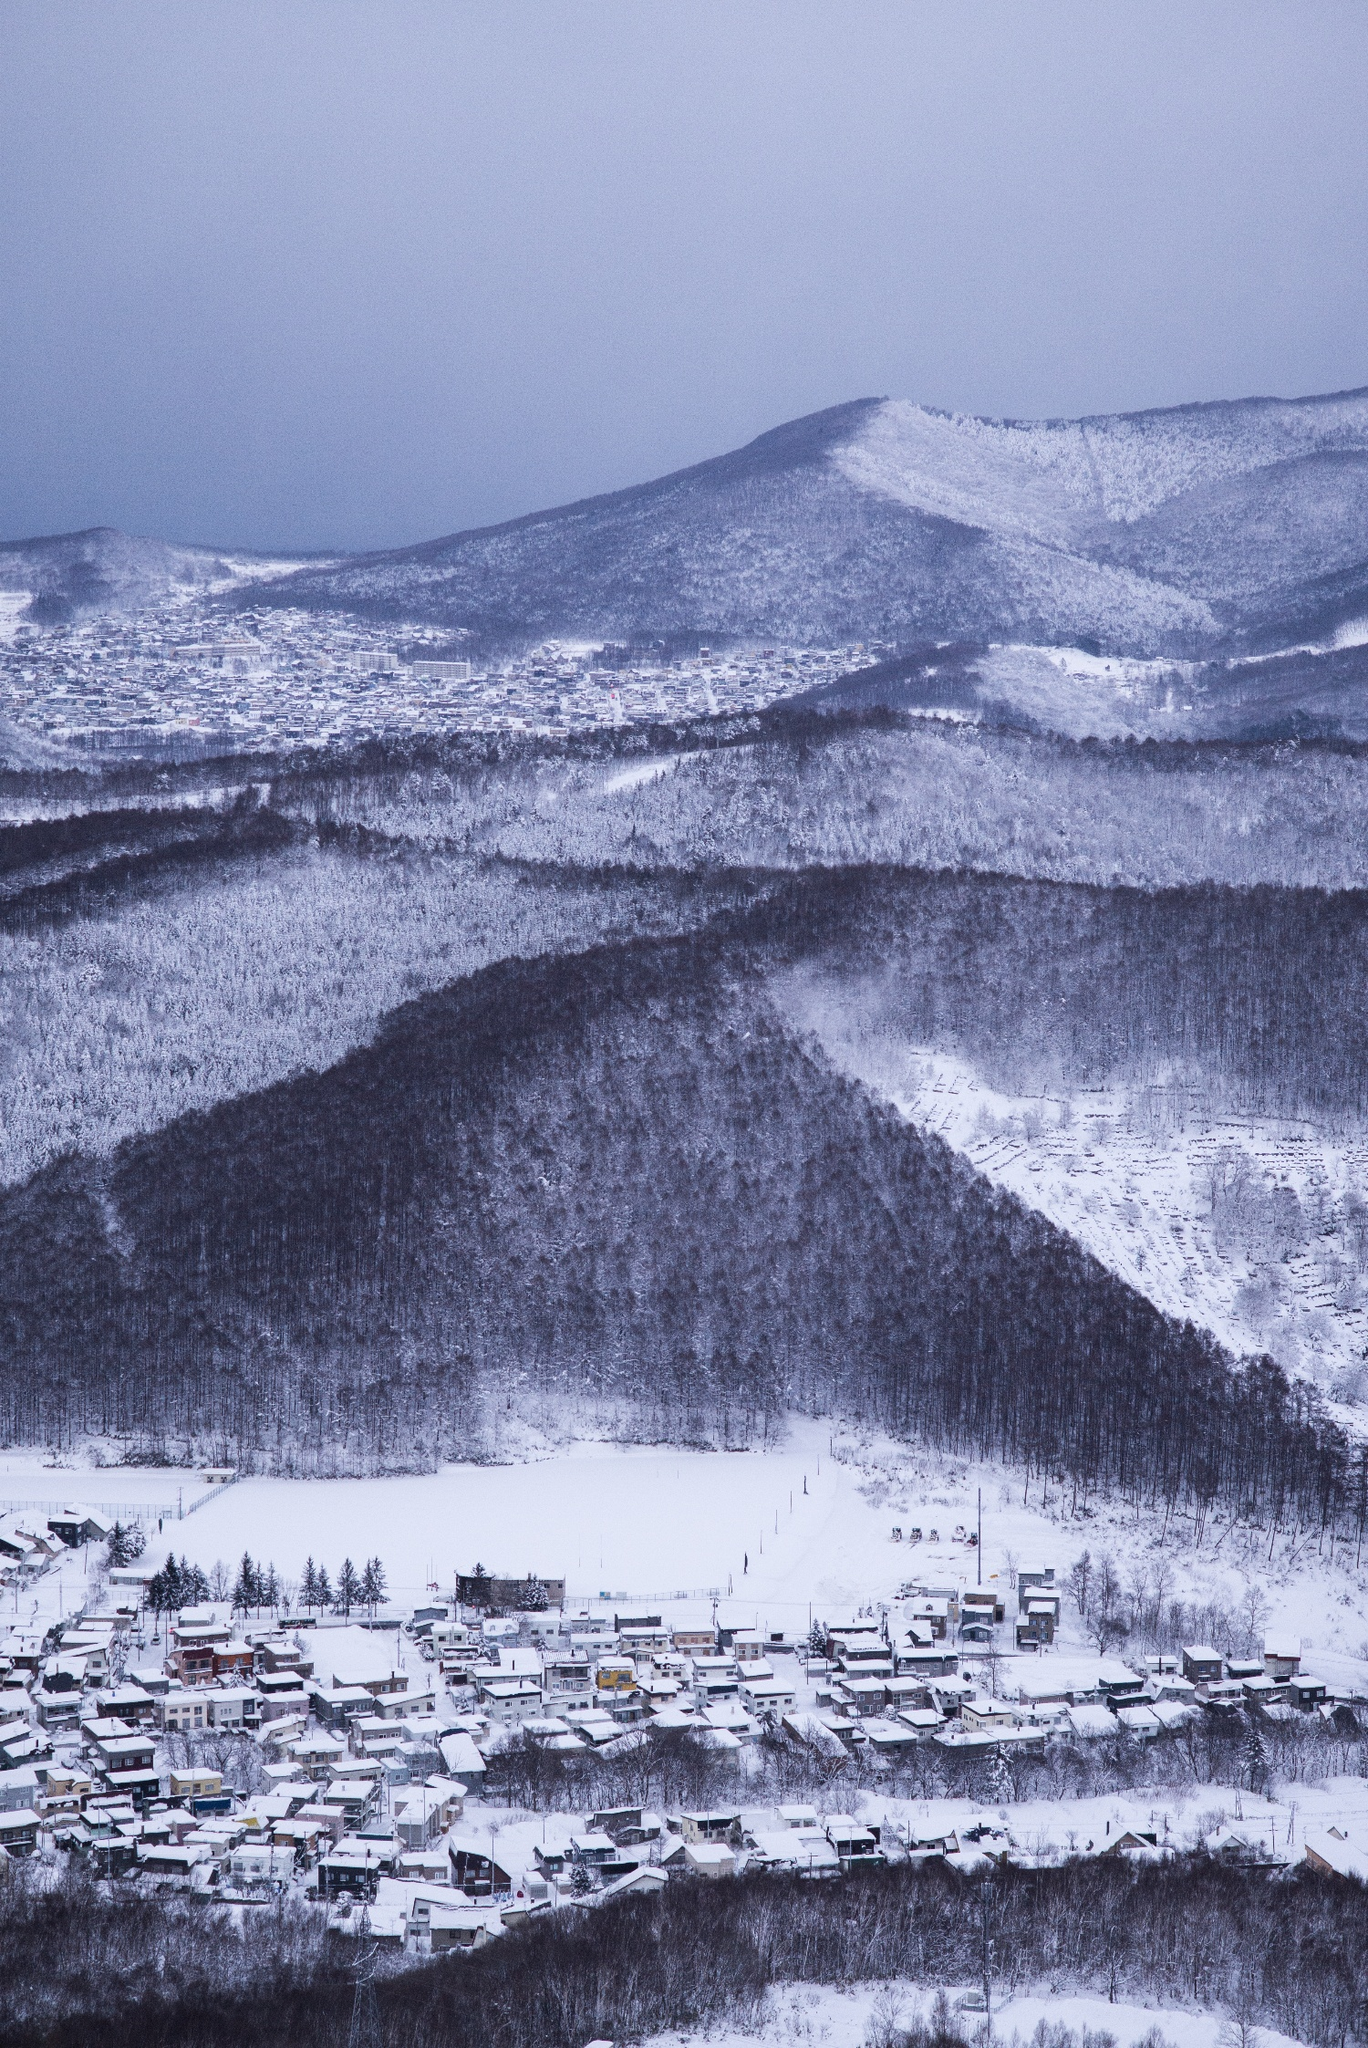Can you describe the environmental impact of living in such a region? Living in such a snow-covered region comes with both challenges and responsibilities concerning environmental impact. The need for heating can lead to increased energy consumption, while isolation can necessitate longer travel distances, contributing to higher carbon emissions. However, the community may also engage in sustainable practices like using renewable energy sources such as geothermal or hydroelectric power, given the natural resources available in mountainous areas. Preservation of the surrounding forest and wildlife management are likely crucial elements of their environmental stewardship. 